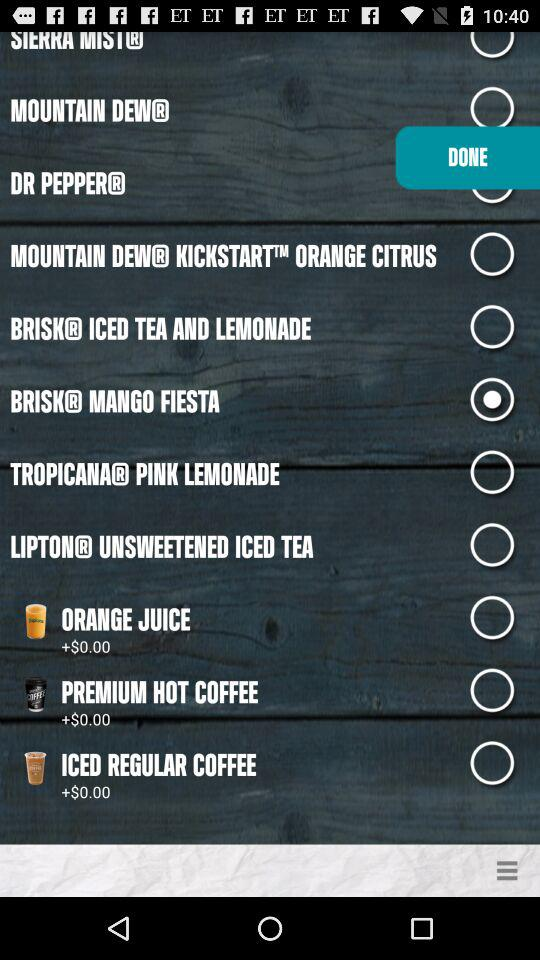What is the price of orange juice? The price is $0.00. 